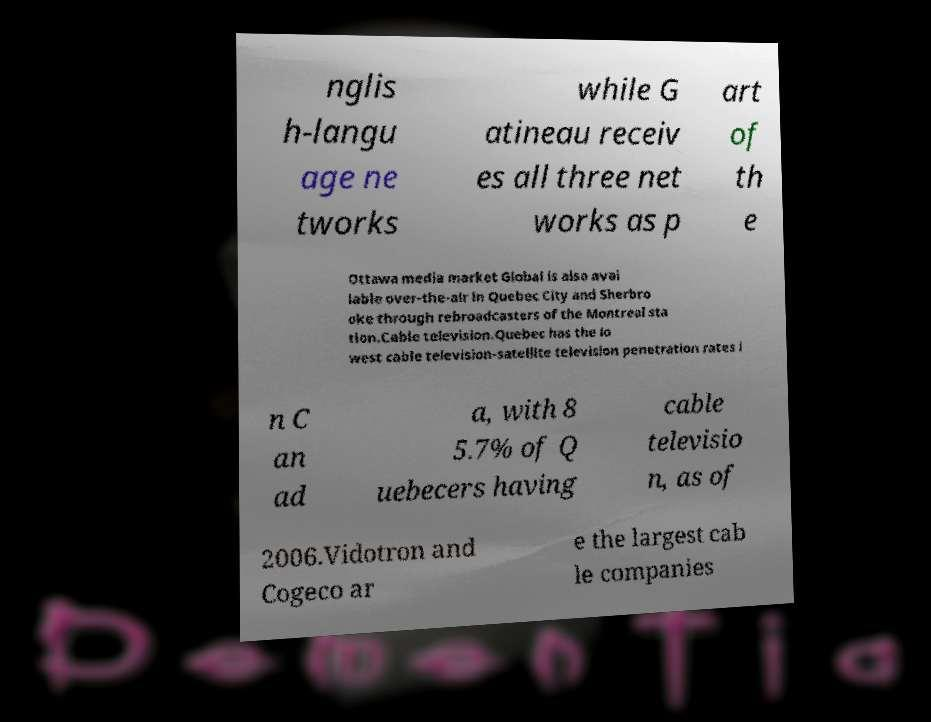Can you accurately transcribe the text from the provided image for me? nglis h-langu age ne tworks while G atineau receiv es all three net works as p art of th e Ottawa media market Global is also avai lable over-the-air in Quebec City and Sherbro oke through rebroadcasters of the Montreal sta tion.Cable television.Quebec has the lo west cable television-satellite television penetration rates i n C an ad a, with 8 5.7% of Q uebecers having cable televisio n, as of 2006.Vidotron and Cogeco ar e the largest cab le companies 